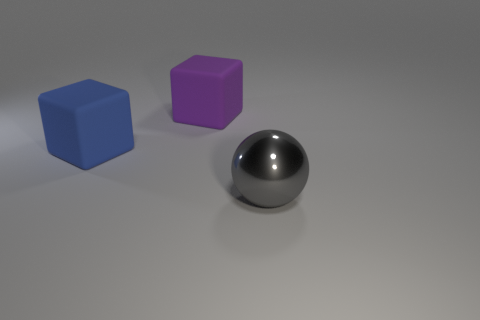What is the material of the gray object?
Your answer should be very brief. Metal. There is a thing that is left of the rubber cube that is on the right side of the big rubber thing that is on the left side of the large purple object; what is its shape?
Offer a terse response. Cube. Is the number of large gray metallic objects that are right of the large gray metal thing greater than the number of big red objects?
Make the answer very short. No. There is a purple object; does it have the same shape as the object that is to the right of the large purple cube?
Your response must be concise. No. There is a large cube that is behind the big block to the left of the purple rubber thing; how many large metallic spheres are behind it?
Ensure brevity in your answer.  0. What is the color of the rubber block that is the same size as the blue object?
Keep it short and to the point. Purple. There is a cube left of the rubber block that is on the right side of the large blue block; how big is it?
Your answer should be very brief. Large. What number of other objects are there of the same size as the blue block?
Provide a succinct answer. 2. What number of gray objects are there?
Ensure brevity in your answer.  1. Is the size of the purple rubber object the same as the gray shiny sphere?
Keep it short and to the point. Yes. 